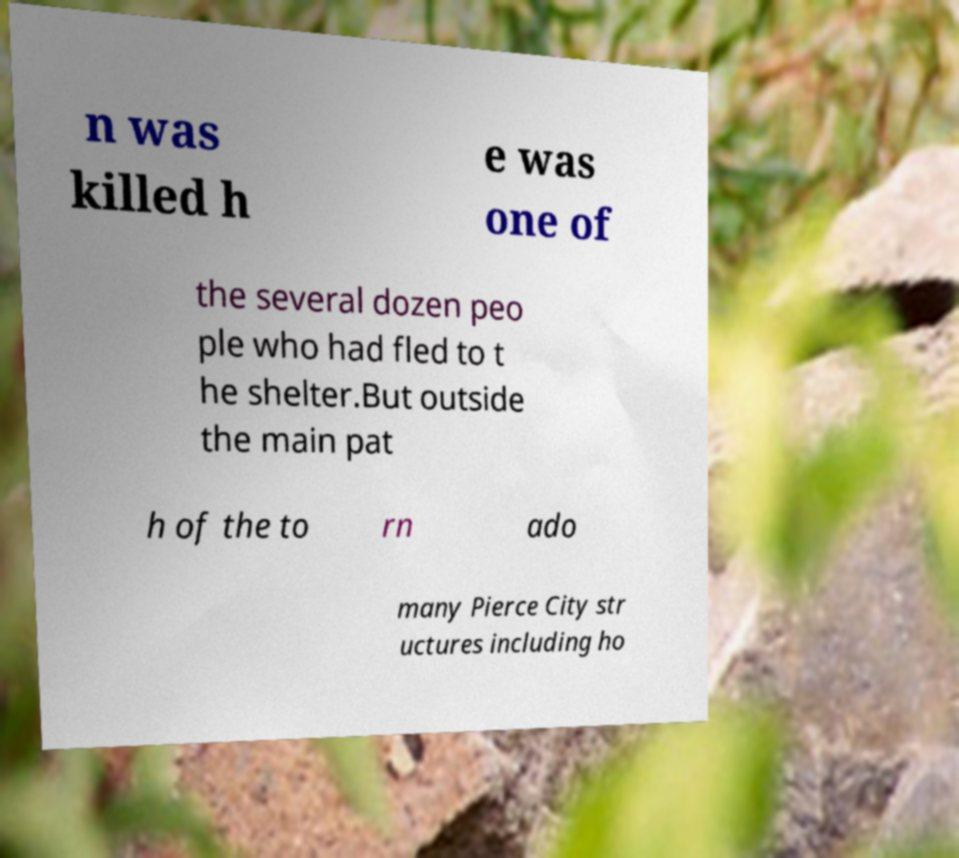For documentation purposes, I need the text within this image transcribed. Could you provide that? n was killed h e was one of the several dozen peo ple who had fled to t he shelter.But outside the main pat h of the to rn ado many Pierce City str uctures including ho 